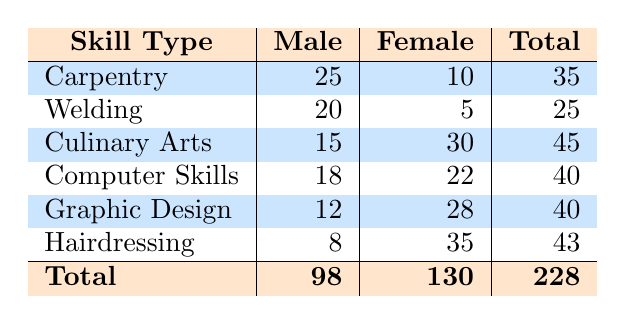What is the total attendance for the "Hairdressing" workshop? By looking at the "Hairdressing" row, the total attendance is the sum of male (8) and female (35) participants, which gives us 8 + 35 = 43.
Answer: 43 How many males attended the "Culinary Arts" workshop? In the "Culinary Arts" row, the attendance for males is directly provided as 15.
Answer: 15 What is the total number of female attendees across all skill types? To find the total number of female attendees, we can sum the female attendance from each skill type: 10 (Carpentry) + 5 (Welding) + 30 (Culinary Arts) + 22 (Computer Skills) + 28 (Graphic Design) + 35 (Hairdressing) = 130.
Answer: 130 Did more females or males attend the "Computer Skills" workshop? In the "Computer Skills" row, 18 males and 22 females attended. Since 22 is greater than 18, more females attended.
Answer: Yes What is the average attendance of males in all workshops? To find the average attendance of males, we first sum the male attendance: 25 (Carpentry) + 20 (Welding) + 15 (Culinary Arts) + 18 (Computer Skills) + 12 (Graphic Design) + 8 (Hairdressing) = 98. There are 6 workshops, so the average is 98 / 6 = approximately 16.33.
Answer: 16.33 Which skill type had the highest attendance overall? By comparing the total attendance for each skill type, we see: Carpentry (35), Welding (25), Culinary Arts (45), Computer Skills (40), Graphic Design (40), and Hairdressing (43). The highest total is for "Culinary Arts" with 45 attendees.
Answer: Culinary Arts Is the total attendance for males greater than that for females? The total attendance for males is 98, and for females, it is 130. Since 98 is less than 130, the statement is false.
Answer: No What is the difference in attendance between the highest attended and lowest attended skill type? The highest attended skill type is "Culinary Arts" with 45 attendees, and the lowest is "Welding" with 25 attendees. The difference is 45 - 25 = 20.
Answer: 20 